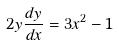<formula> <loc_0><loc_0><loc_500><loc_500>2 y \frac { d y } { d x } = 3 x ^ { 2 } - 1</formula> 